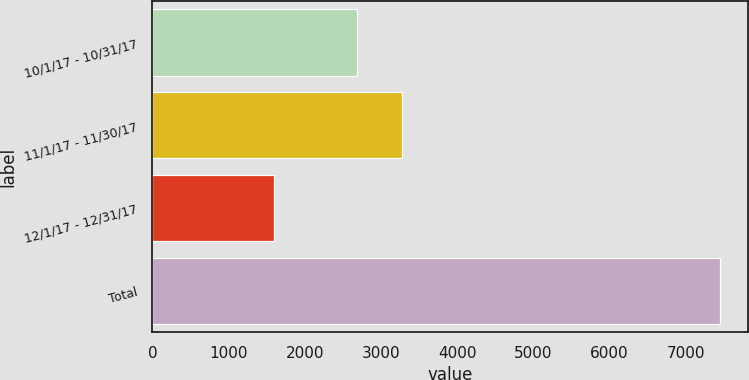Convert chart. <chart><loc_0><loc_0><loc_500><loc_500><bar_chart><fcel>10/1/17 - 10/31/17<fcel>11/1/17 - 11/30/17<fcel>12/1/17 - 12/31/17<fcel>Total<nl><fcel>2686<fcel>3270.8<fcel>1603<fcel>7451<nl></chart> 